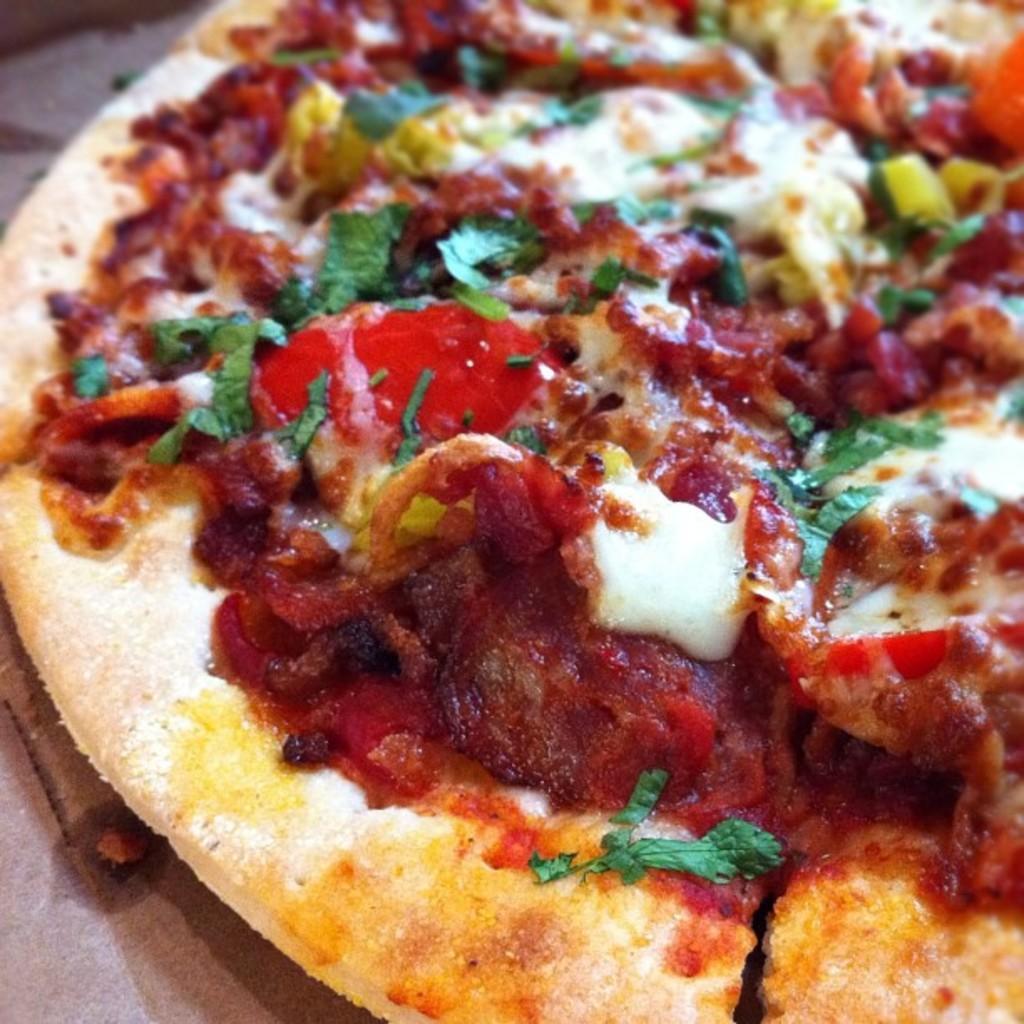In one or two sentences, can you explain what this image depicts? In this image we can see a pizza. 